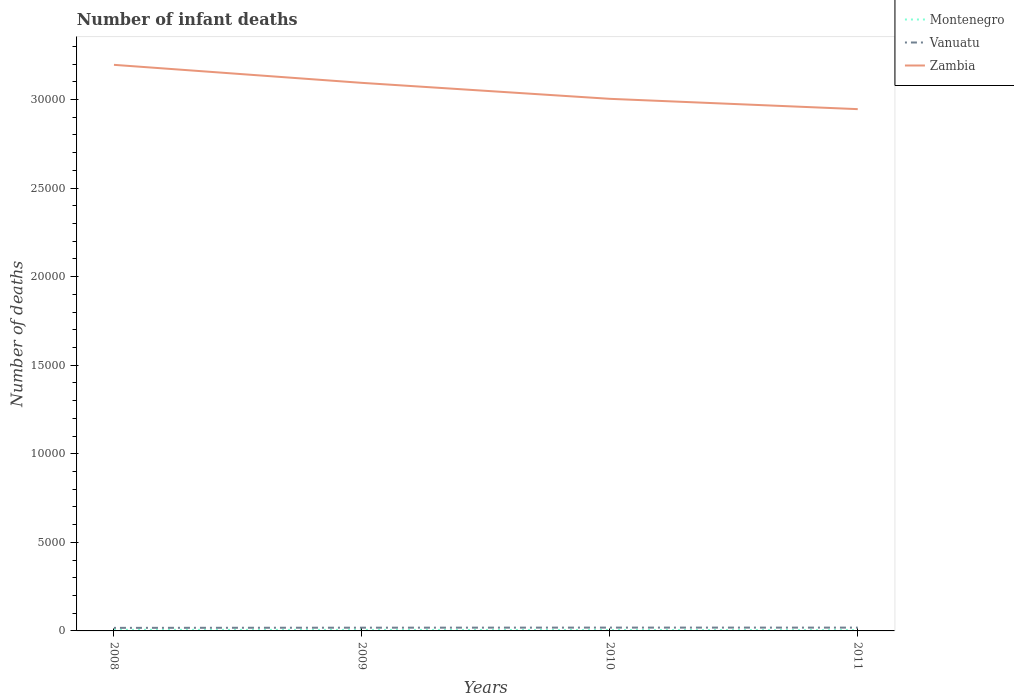How many different coloured lines are there?
Ensure brevity in your answer.  3. Does the line corresponding to Zambia intersect with the line corresponding to Vanuatu?
Your answer should be compact. No. Across all years, what is the maximum number of infant deaths in Zambia?
Give a very brief answer. 2.95e+04. What is the total number of infant deaths in Montenegro in the graph?
Offer a terse response. 11. What is the difference between the highest and the second highest number of infant deaths in Vanuatu?
Provide a succinct answer. 15. How many lines are there?
Your answer should be compact. 3. Are the values on the major ticks of Y-axis written in scientific E-notation?
Provide a succinct answer. No. Does the graph contain any zero values?
Your answer should be very brief. No. Where does the legend appear in the graph?
Offer a terse response. Top right. How many legend labels are there?
Keep it short and to the point. 3. What is the title of the graph?
Offer a very short reply. Number of infant deaths. What is the label or title of the Y-axis?
Your response must be concise. Number of deaths. What is the Number of deaths in Vanuatu in 2008?
Provide a succinct answer. 173. What is the Number of deaths in Zambia in 2008?
Make the answer very short. 3.20e+04. What is the Number of deaths of Montenegro in 2009?
Make the answer very short. 57. What is the Number of deaths of Vanuatu in 2009?
Provide a short and direct response. 183. What is the Number of deaths of Zambia in 2009?
Provide a succinct answer. 3.09e+04. What is the Number of deaths in Montenegro in 2010?
Your answer should be very brief. 52. What is the Number of deaths of Vanuatu in 2010?
Provide a short and direct response. 188. What is the Number of deaths of Zambia in 2010?
Offer a very short reply. 3.00e+04. What is the Number of deaths in Vanuatu in 2011?
Offer a very short reply. 187. What is the Number of deaths of Zambia in 2011?
Offer a terse response. 2.95e+04. Across all years, what is the maximum Number of deaths of Vanuatu?
Your response must be concise. 188. Across all years, what is the maximum Number of deaths in Zambia?
Make the answer very short. 3.20e+04. Across all years, what is the minimum Number of deaths in Vanuatu?
Your answer should be compact. 173. Across all years, what is the minimum Number of deaths of Zambia?
Provide a succinct answer. 2.95e+04. What is the total Number of deaths of Montenegro in the graph?
Make the answer very short. 217. What is the total Number of deaths of Vanuatu in the graph?
Offer a terse response. 731. What is the total Number of deaths of Zambia in the graph?
Give a very brief answer. 1.22e+05. What is the difference between the Number of deaths in Montenegro in 2008 and that in 2009?
Offer a very short reply. 5. What is the difference between the Number of deaths in Vanuatu in 2008 and that in 2009?
Provide a succinct answer. -10. What is the difference between the Number of deaths in Zambia in 2008 and that in 2009?
Offer a very short reply. 1017. What is the difference between the Number of deaths in Zambia in 2008 and that in 2010?
Give a very brief answer. 1919. What is the difference between the Number of deaths in Montenegro in 2008 and that in 2011?
Ensure brevity in your answer.  16. What is the difference between the Number of deaths in Zambia in 2008 and that in 2011?
Your answer should be compact. 2501. What is the difference between the Number of deaths in Zambia in 2009 and that in 2010?
Your answer should be compact. 902. What is the difference between the Number of deaths in Montenegro in 2009 and that in 2011?
Provide a succinct answer. 11. What is the difference between the Number of deaths of Vanuatu in 2009 and that in 2011?
Give a very brief answer. -4. What is the difference between the Number of deaths of Zambia in 2009 and that in 2011?
Your answer should be very brief. 1484. What is the difference between the Number of deaths in Zambia in 2010 and that in 2011?
Provide a short and direct response. 582. What is the difference between the Number of deaths in Montenegro in 2008 and the Number of deaths in Vanuatu in 2009?
Ensure brevity in your answer.  -121. What is the difference between the Number of deaths in Montenegro in 2008 and the Number of deaths in Zambia in 2009?
Give a very brief answer. -3.09e+04. What is the difference between the Number of deaths of Vanuatu in 2008 and the Number of deaths of Zambia in 2009?
Offer a very short reply. -3.08e+04. What is the difference between the Number of deaths of Montenegro in 2008 and the Number of deaths of Vanuatu in 2010?
Your response must be concise. -126. What is the difference between the Number of deaths of Montenegro in 2008 and the Number of deaths of Zambia in 2010?
Make the answer very short. -3.00e+04. What is the difference between the Number of deaths in Vanuatu in 2008 and the Number of deaths in Zambia in 2010?
Ensure brevity in your answer.  -2.99e+04. What is the difference between the Number of deaths in Montenegro in 2008 and the Number of deaths in Vanuatu in 2011?
Keep it short and to the point. -125. What is the difference between the Number of deaths in Montenegro in 2008 and the Number of deaths in Zambia in 2011?
Your response must be concise. -2.94e+04. What is the difference between the Number of deaths of Vanuatu in 2008 and the Number of deaths of Zambia in 2011?
Your answer should be very brief. -2.93e+04. What is the difference between the Number of deaths of Montenegro in 2009 and the Number of deaths of Vanuatu in 2010?
Your answer should be very brief. -131. What is the difference between the Number of deaths in Montenegro in 2009 and the Number of deaths in Zambia in 2010?
Provide a short and direct response. -3.00e+04. What is the difference between the Number of deaths in Vanuatu in 2009 and the Number of deaths in Zambia in 2010?
Make the answer very short. -2.99e+04. What is the difference between the Number of deaths in Montenegro in 2009 and the Number of deaths in Vanuatu in 2011?
Your answer should be compact. -130. What is the difference between the Number of deaths of Montenegro in 2009 and the Number of deaths of Zambia in 2011?
Offer a terse response. -2.94e+04. What is the difference between the Number of deaths of Vanuatu in 2009 and the Number of deaths of Zambia in 2011?
Offer a terse response. -2.93e+04. What is the difference between the Number of deaths of Montenegro in 2010 and the Number of deaths of Vanuatu in 2011?
Provide a succinct answer. -135. What is the difference between the Number of deaths of Montenegro in 2010 and the Number of deaths of Zambia in 2011?
Make the answer very short. -2.94e+04. What is the difference between the Number of deaths in Vanuatu in 2010 and the Number of deaths in Zambia in 2011?
Ensure brevity in your answer.  -2.93e+04. What is the average Number of deaths in Montenegro per year?
Provide a short and direct response. 54.25. What is the average Number of deaths of Vanuatu per year?
Offer a very short reply. 182.75. What is the average Number of deaths in Zambia per year?
Your answer should be compact. 3.06e+04. In the year 2008, what is the difference between the Number of deaths in Montenegro and Number of deaths in Vanuatu?
Give a very brief answer. -111. In the year 2008, what is the difference between the Number of deaths of Montenegro and Number of deaths of Zambia?
Offer a very short reply. -3.19e+04. In the year 2008, what is the difference between the Number of deaths in Vanuatu and Number of deaths in Zambia?
Offer a terse response. -3.18e+04. In the year 2009, what is the difference between the Number of deaths of Montenegro and Number of deaths of Vanuatu?
Give a very brief answer. -126. In the year 2009, what is the difference between the Number of deaths of Montenegro and Number of deaths of Zambia?
Offer a terse response. -3.09e+04. In the year 2009, what is the difference between the Number of deaths in Vanuatu and Number of deaths in Zambia?
Your answer should be very brief. -3.08e+04. In the year 2010, what is the difference between the Number of deaths in Montenegro and Number of deaths in Vanuatu?
Offer a very short reply. -136. In the year 2010, what is the difference between the Number of deaths of Montenegro and Number of deaths of Zambia?
Keep it short and to the point. -3.00e+04. In the year 2010, what is the difference between the Number of deaths in Vanuatu and Number of deaths in Zambia?
Give a very brief answer. -2.98e+04. In the year 2011, what is the difference between the Number of deaths in Montenegro and Number of deaths in Vanuatu?
Give a very brief answer. -141. In the year 2011, what is the difference between the Number of deaths in Montenegro and Number of deaths in Zambia?
Make the answer very short. -2.94e+04. In the year 2011, what is the difference between the Number of deaths in Vanuatu and Number of deaths in Zambia?
Offer a terse response. -2.93e+04. What is the ratio of the Number of deaths of Montenegro in 2008 to that in 2009?
Give a very brief answer. 1.09. What is the ratio of the Number of deaths of Vanuatu in 2008 to that in 2009?
Your response must be concise. 0.95. What is the ratio of the Number of deaths of Zambia in 2008 to that in 2009?
Your response must be concise. 1.03. What is the ratio of the Number of deaths in Montenegro in 2008 to that in 2010?
Provide a succinct answer. 1.19. What is the ratio of the Number of deaths in Vanuatu in 2008 to that in 2010?
Your answer should be compact. 0.92. What is the ratio of the Number of deaths of Zambia in 2008 to that in 2010?
Make the answer very short. 1.06. What is the ratio of the Number of deaths of Montenegro in 2008 to that in 2011?
Keep it short and to the point. 1.35. What is the ratio of the Number of deaths in Vanuatu in 2008 to that in 2011?
Offer a terse response. 0.93. What is the ratio of the Number of deaths in Zambia in 2008 to that in 2011?
Make the answer very short. 1.08. What is the ratio of the Number of deaths in Montenegro in 2009 to that in 2010?
Offer a very short reply. 1.1. What is the ratio of the Number of deaths of Vanuatu in 2009 to that in 2010?
Provide a short and direct response. 0.97. What is the ratio of the Number of deaths in Zambia in 2009 to that in 2010?
Make the answer very short. 1.03. What is the ratio of the Number of deaths of Montenegro in 2009 to that in 2011?
Provide a short and direct response. 1.24. What is the ratio of the Number of deaths in Vanuatu in 2009 to that in 2011?
Make the answer very short. 0.98. What is the ratio of the Number of deaths in Zambia in 2009 to that in 2011?
Your response must be concise. 1.05. What is the ratio of the Number of deaths in Montenegro in 2010 to that in 2011?
Ensure brevity in your answer.  1.13. What is the ratio of the Number of deaths in Zambia in 2010 to that in 2011?
Your answer should be compact. 1.02. What is the difference between the highest and the second highest Number of deaths of Montenegro?
Offer a terse response. 5. What is the difference between the highest and the second highest Number of deaths of Zambia?
Give a very brief answer. 1017. What is the difference between the highest and the lowest Number of deaths of Zambia?
Your answer should be very brief. 2501. 